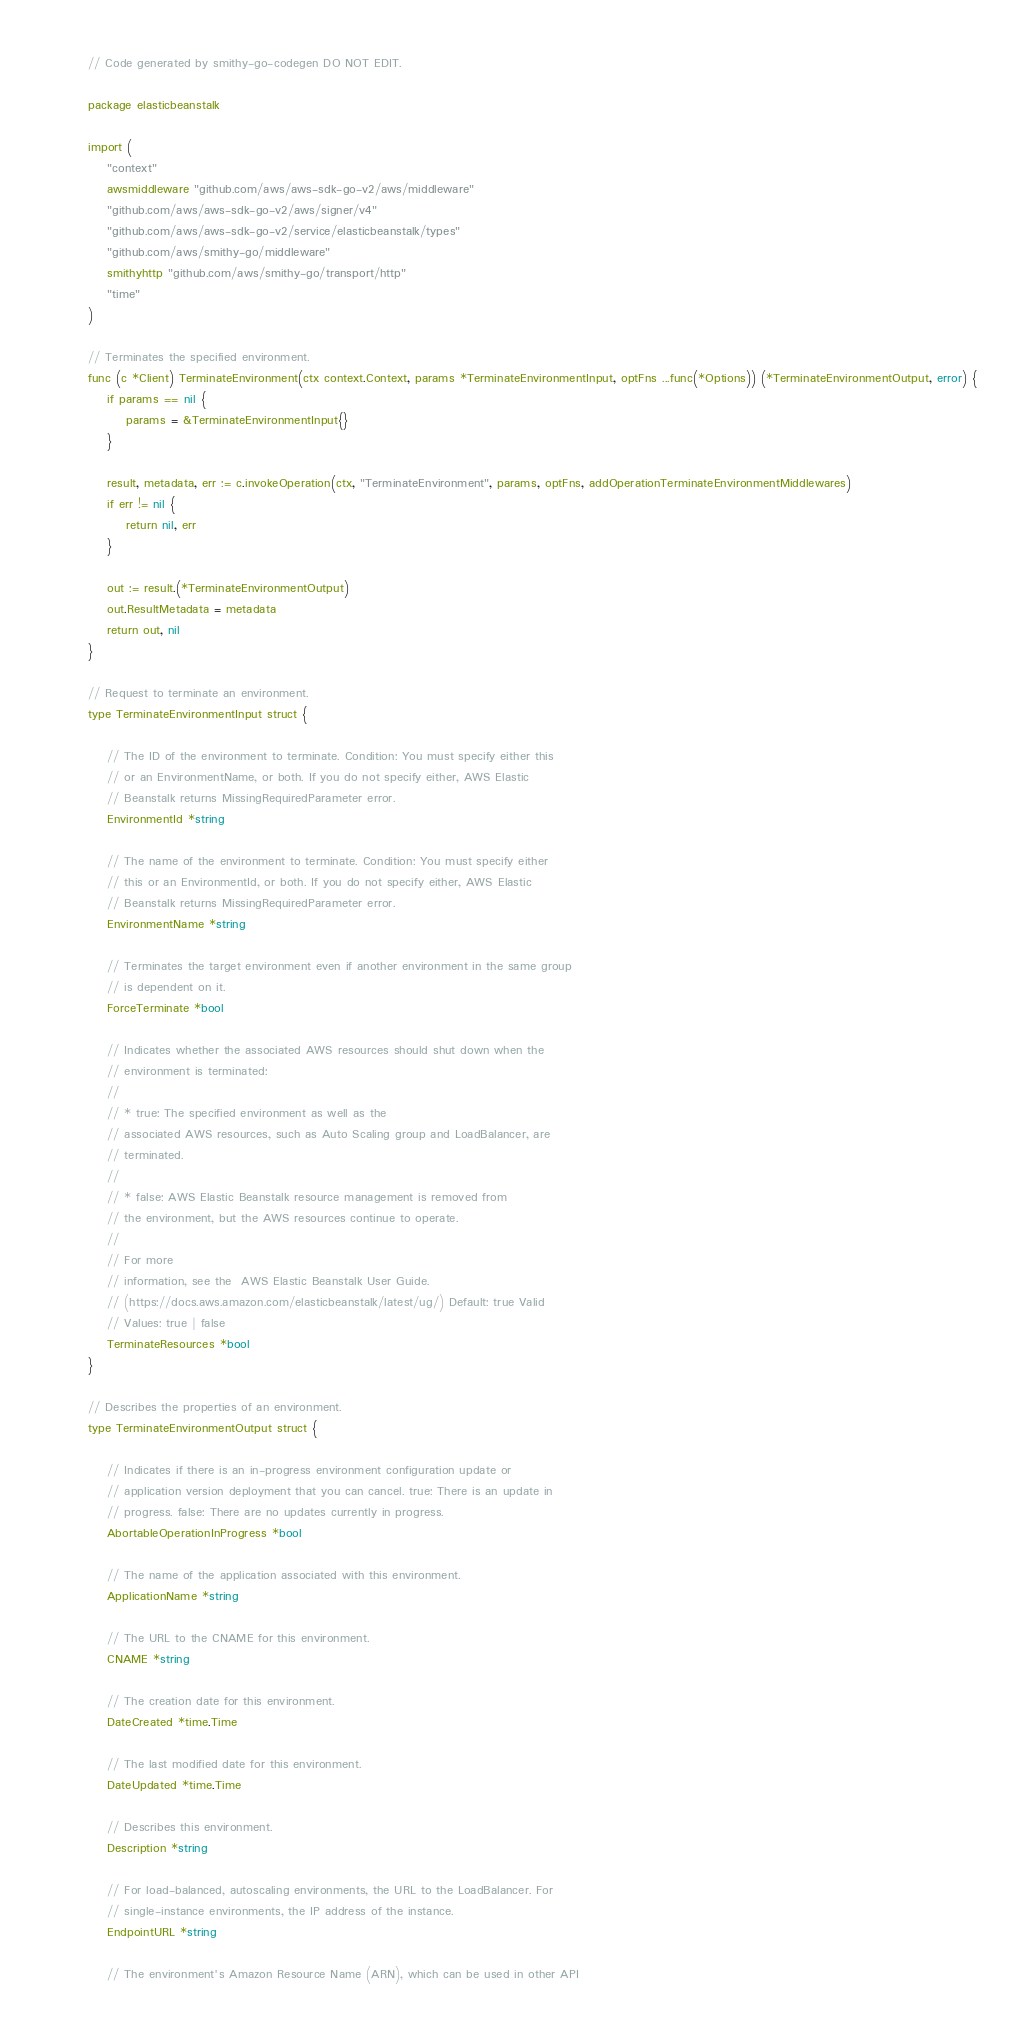Convert code to text. <code><loc_0><loc_0><loc_500><loc_500><_Go_>// Code generated by smithy-go-codegen DO NOT EDIT.

package elasticbeanstalk

import (
	"context"
	awsmiddleware "github.com/aws/aws-sdk-go-v2/aws/middleware"
	"github.com/aws/aws-sdk-go-v2/aws/signer/v4"
	"github.com/aws/aws-sdk-go-v2/service/elasticbeanstalk/types"
	"github.com/aws/smithy-go/middleware"
	smithyhttp "github.com/aws/smithy-go/transport/http"
	"time"
)

// Terminates the specified environment.
func (c *Client) TerminateEnvironment(ctx context.Context, params *TerminateEnvironmentInput, optFns ...func(*Options)) (*TerminateEnvironmentOutput, error) {
	if params == nil {
		params = &TerminateEnvironmentInput{}
	}

	result, metadata, err := c.invokeOperation(ctx, "TerminateEnvironment", params, optFns, addOperationTerminateEnvironmentMiddlewares)
	if err != nil {
		return nil, err
	}

	out := result.(*TerminateEnvironmentOutput)
	out.ResultMetadata = metadata
	return out, nil
}

// Request to terminate an environment.
type TerminateEnvironmentInput struct {

	// The ID of the environment to terminate. Condition: You must specify either this
	// or an EnvironmentName, or both. If you do not specify either, AWS Elastic
	// Beanstalk returns MissingRequiredParameter error.
	EnvironmentId *string

	// The name of the environment to terminate. Condition: You must specify either
	// this or an EnvironmentId, or both. If you do not specify either, AWS Elastic
	// Beanstalk returns MissingRequiredParameter error.
	EnvironmentName *string

	// Terminates the target environment even if another environment in the same group
	// is dependent on it.
	ForceTerminate *bool

	// Indicates whether the associated AWS resources should shut down when the
	// environment is terminated:
	//
	// * true: The specified environment as well as the
	// associated AWS resources, such as Auto Scaling group and LoadBalancer, are
	// terminated.
	//
	// * false: AWS Elastic Beanstalk resource management is removed from
	// the environment, but the AWS resources continue to operate.
	//
	// For more
	// information, see the  AWS Elastic Beanstalk User Guide.
	// (https://docs.aws.amazon.com/elasticbeanstalk/latest/ug/) Default: true Valid
	// Values: true | false
	TerminateResources *bool
}

// Describes the properties of an environment.
type TerminateEnvironmentOutput struct {

	// Indicates if there is an in-progress environment configuration update or
	// application version deployment that you can cancel. true: There is an update in
	// progress. false: There are no updates currently in progress.
	AbortableOperationInProgress *bool

	// The name of the application associated with this environment.
	ApplicationName *string

	// The URL to the CNAME for this environment.
	CNAME *string

	// The creation date for this environment.
	DateCreated *time.Time

	// The last modified date for this environment.
	DateUpdated *time.Time

	// Describes this environment.
	Description *string

	// For load-balanced, autoscaling environments, the URL to the LoadBalancer. For
	// single-instance environments, the IP address of the instance.
	EndpointURL *string

	// The environment's Amazon Resource Name (ARN), which can be used in other API</code> 